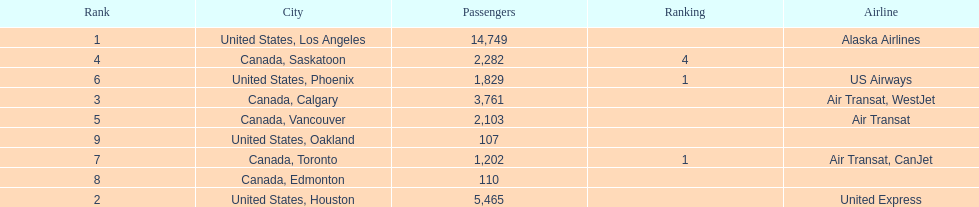Which airline carries the most passengers? Alaska Airlines. 